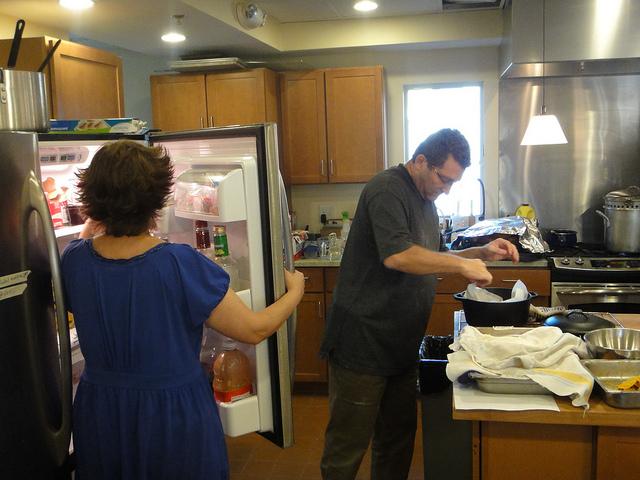Who had the fridge door open?
Quick response, please. Woman. Is the lady cooking a meal?
Write a very short answer. No. What color is the woman's dress?
Quick response, please. Blue. 